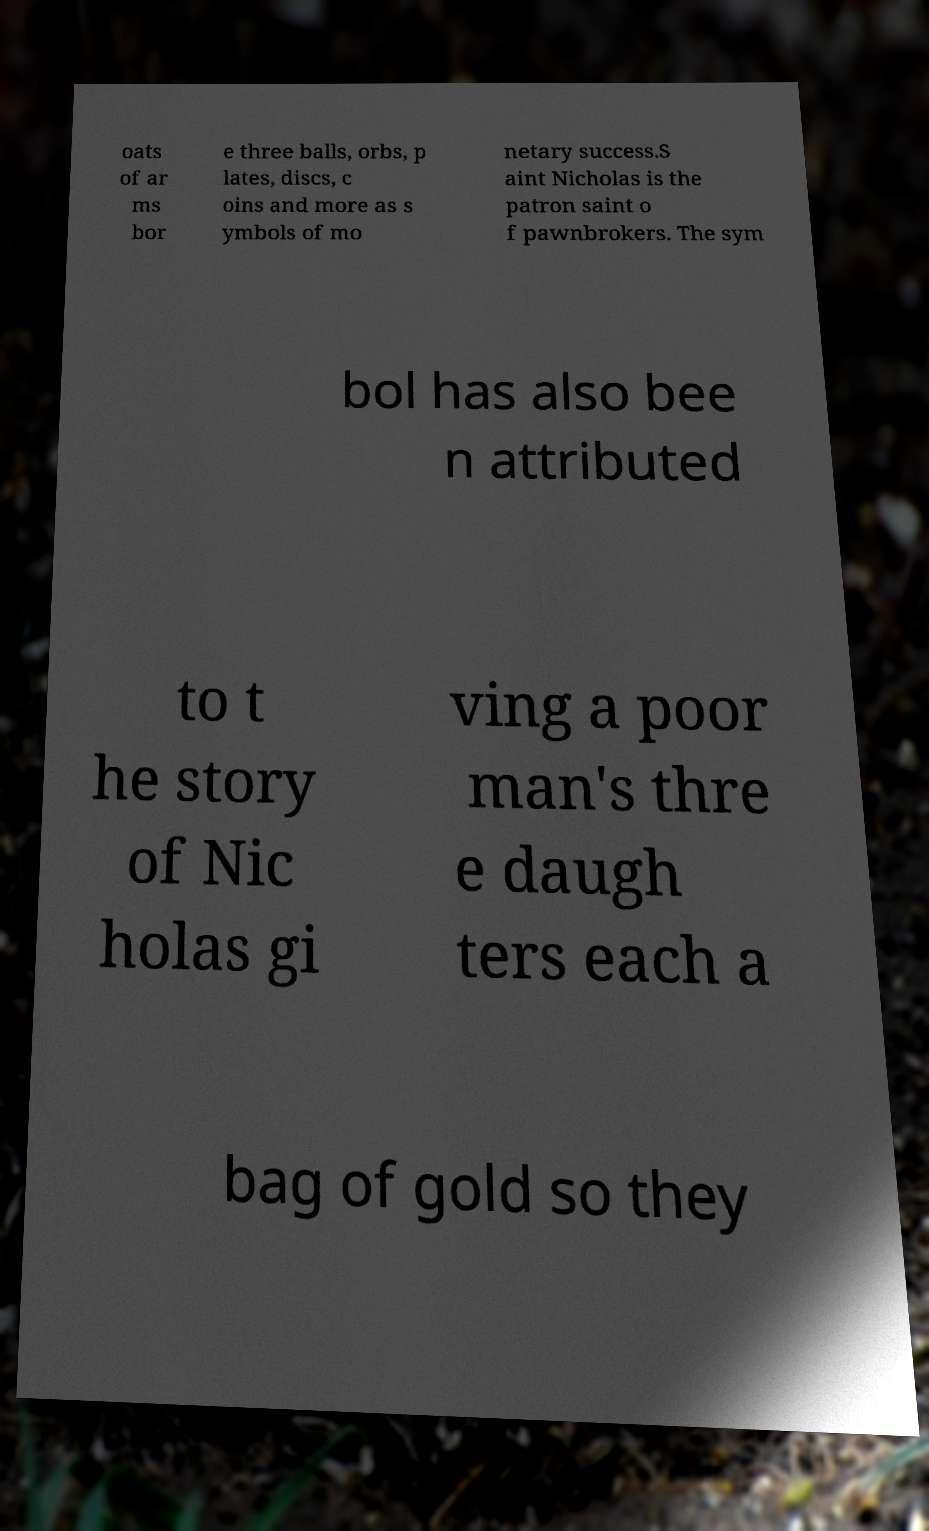What messages or text are displayed in this image? I need them in a readable, typed format. oats of ar ms bor e three balls, orbs, p lates, discs, c oins and more as s ymbols of mo netary success.S aint Nicholas is the patron saint o f pawnbrokers. The sym bol has also bee n attributed to t he story of Nic holas gi ving a poor man's thre e daugh ters each a bag of gold so they 